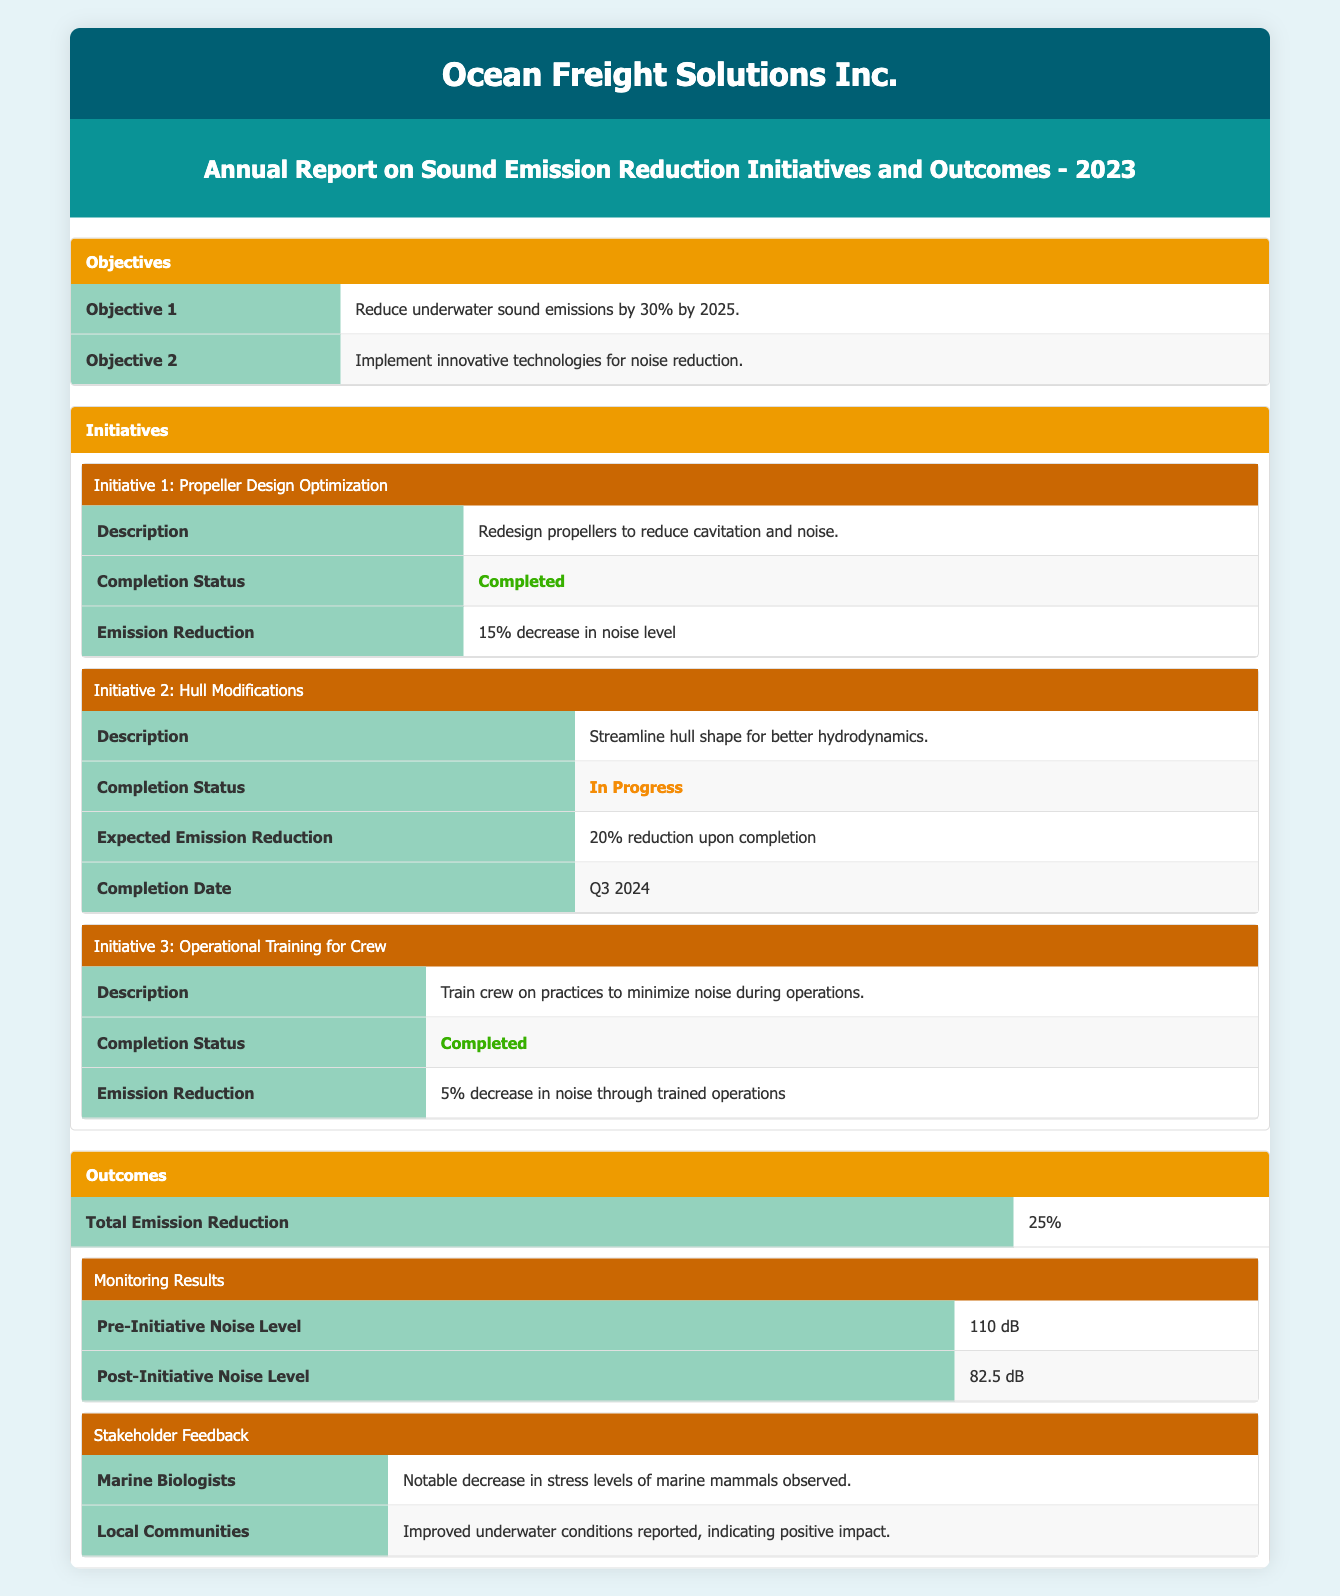What is the objective for reducing underwater sound emissions? The table states that the first objective is "Reduce underwater sound emissions by 30% by 2025." This can be directly retrieved from the "Objectives" section.
Answer: Reduce underwater sound emissions by 30% by 2025 Which initiative has been completed? By examining the "Completion Status" in the "Initiatives" section, I can see that both "Propeller Design Optimization" and "Operational Training for Crew" have the status "Completed." Therefore, the answer is specific to those initiatives.
Answer: Propeller Design Optimization and Operational Training for Crew What is the expected emission reduction from Hull Modifications? I can find this information in the "Initiative2" section where it states "Expected Emission Reduction: 20% reduction upon completion."
Answer: 20% reduction upon completion How much noise reduction was achieved through the completed initiatives? The completed initiatives are "Propeller Design Optimization" (15% reduction) and "Operational Training for Crew" (5% reduction). Summing these gives a total of 20% noise reduction from completed initiatives.
Answer: 20% noise reduction Did monitoring results show a decrease in noise level post-initiatives? According to the "Monitoring Results" section, the pre-initiative noise level was 110 dB and the post-initiative noise level was 82.5 dB. Since 82.5 dB is less than 110 dB, this confirms that there was a decrease in noise level.
Answer: Yes What is the total emission reduction achieved so far? The "Outcomes" section explicitly states "Total Emission Reduction: 25%." This is directly retrievable from the table.
Answer: 25% How much noise level was reduced in terms of decibels? The difference between the pre-initiative noise level (110 dB) and the post-initiative noise level (82.5 dB) gives the reduction. Calculating this gives: 110 dB - 82.5 dB = 27.5 dB.
Answer: 27.5 dB What was the feedback from local communities? The table includes a section for "Stakeholder Feedback," where local communities reported "Improved underwater conditions reported, indicating positive impact." This comment can be found in the relevant subsection.
Answer: Improved underwater conditions reported, indicating positive impact Is the completion status of Hull Modifications marked as completed? In the "Initiatives" section, the completion status for Hull Modifications is listed as "In Progress," which means it has not yet been completed. Thus, the answer is based on the available information in this section.
Answer: No 